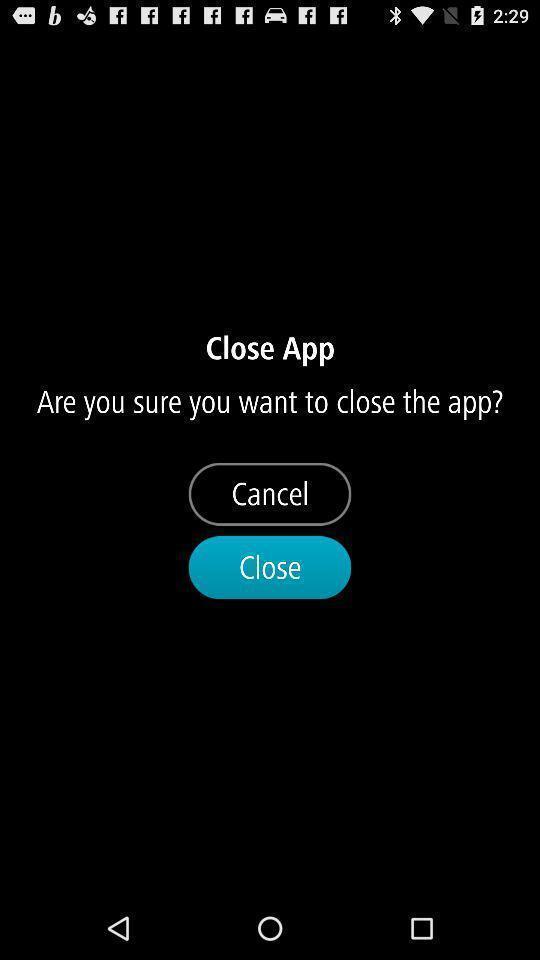Give me a summary of this screen capture. Page showing cancel and close options. 